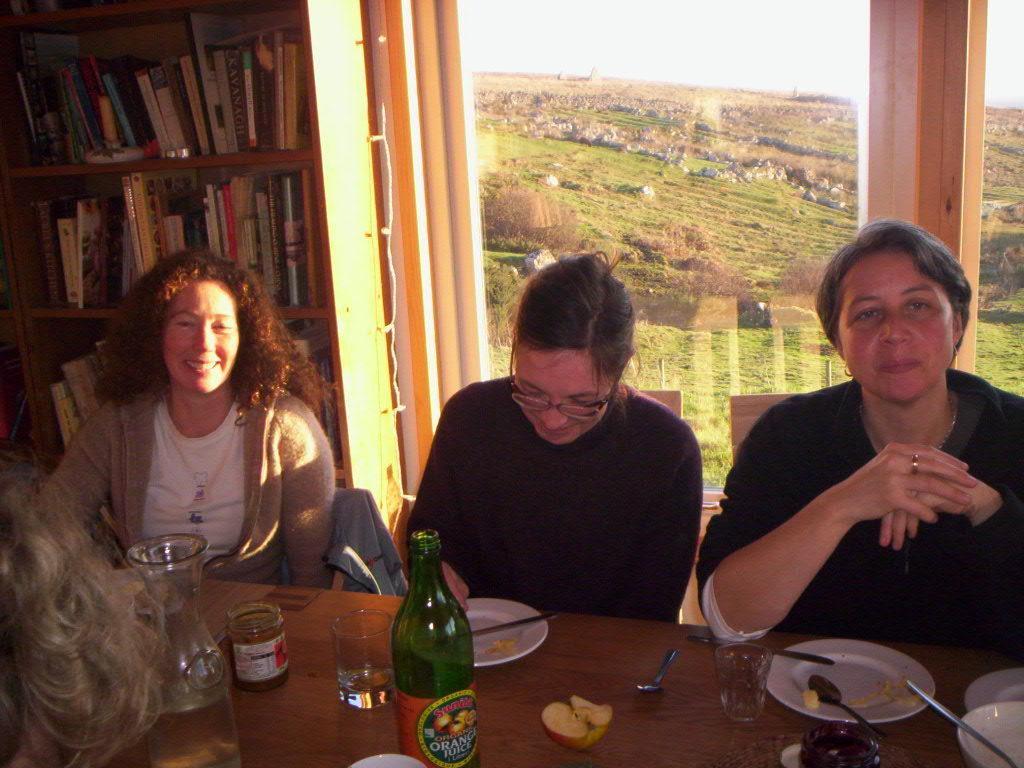Describe this image in one or two sentences. There are three persons sitting in front of a table which has some eatables and drinks on it and there is a book shelf and a greenery ground behind them. 